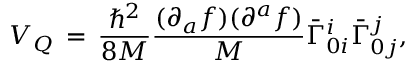Convert formula to latex. <formula><loc_0><loc_0><loc_500><loc_500>V _ { Q } \, = \, \frac { { } ^ { 2 } } { 8 M } \frac { ( \partial _ { a } f ) ( \partial ^ { a } f ) } { M } { \bar { \Gamma } } _ { 0 i } ^ { i } { \bar { \Gamma } } _ { 0 j } ^ { j } ,</formula> 